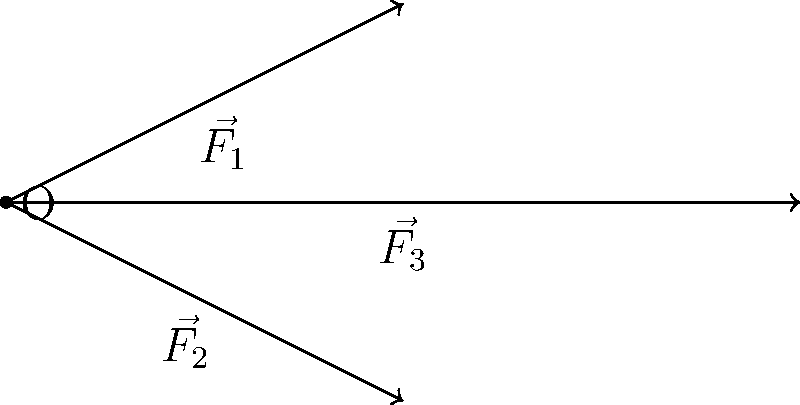Kelly Hecking, your favorite swimmer, is analyzing the efficiency of different swimming strokes using force vector diagrams. The diagram above shows three force vectors representing different components of a swimming stroke: $\vec{F_1}$ (arm pull), $\vec{F_2}$ (leg kick), and $\vec{F_3}$ (body rotation). If the magnitude of $\vec{F_1}$ is 200 N and $\vec{F_2}$ is 150 N, what should be the magnitude of $\vec{F_3}$ to maximize the total force in the forward direction? Let's approach this step-by-step:

1) First, we need to understand that the most efficient stroke will maximize the force in the forward direction (horizontal axis in this case).

2) From the diagram, we can see that:
   $\vec{F_1}$ = (2, 1)
   $\vec{F_2}$ = (2, -1)
   $\vec{F_3}$ = (4, 0)

3) To normalize these vectors, we need to find their magnitudes:
   $|\vec{F_1}| = \sqrt{2^2 + 1^2} = \sqrt{5}$
   $|\vec{F_2}| = \sqrt{2^2 + (-1)^2} = \sqrt{5}$
   $|\vec{F_3}| = \sqrt{4^2 + 0^2} = 4$

4) Now, we can express each vector in terms of its given magnitude:
   $\vec{F_1} = 200 \cdot (\frac{2}{\sqrt{5}}, \frac{1}{\sqrt{5}})$
   $\vec{F_2} = 150 \cdot (\frac{2}{\sqrt{5}}, \frac{-1}{\sqrt{5}})$
   $\vec{F_3} = x \cdot (1, 0)$, where x is the unknown magnitude we're solving for

5) Adding these vectors:
   $\vec{F_{total}} = (200 \cdot \frac{2}{\sqrt{5}} + 150 \cdot \frac{2}{\sqrt{5}} + x, 200 \cdot \frac{1}{\sqrt{5}} - 150 \cdot \frac{1}{\sqrt{5}})$

6) To maximize the forward force, we want the y-component to be zero:
   $200 \cdot \frac{1}{\sqrt{5}} - 150 \cdot \frac{1}{\sqrt{5}} = 0$
   This is already true, so we don't need to adjust $\vec{F_3}$ vertically.

7) The x-component of the total force is:
   $200 \cdot \frac{2}{\sqrt{5}} + 150 \cdot \frac{2}{\sqrt{5}} + x$

8) To maximize this, we simply need to make x (the magnitude of $\vec{F_3}$) as large as possible within the swimmer's capabilities.

Therefore, the magnitude of $\vec{F_3}$ should be as large as Kelly Hecking can generate while maintaining proper form and technique.
Answer: Maximum possible magnitude while maintaining proper technique 